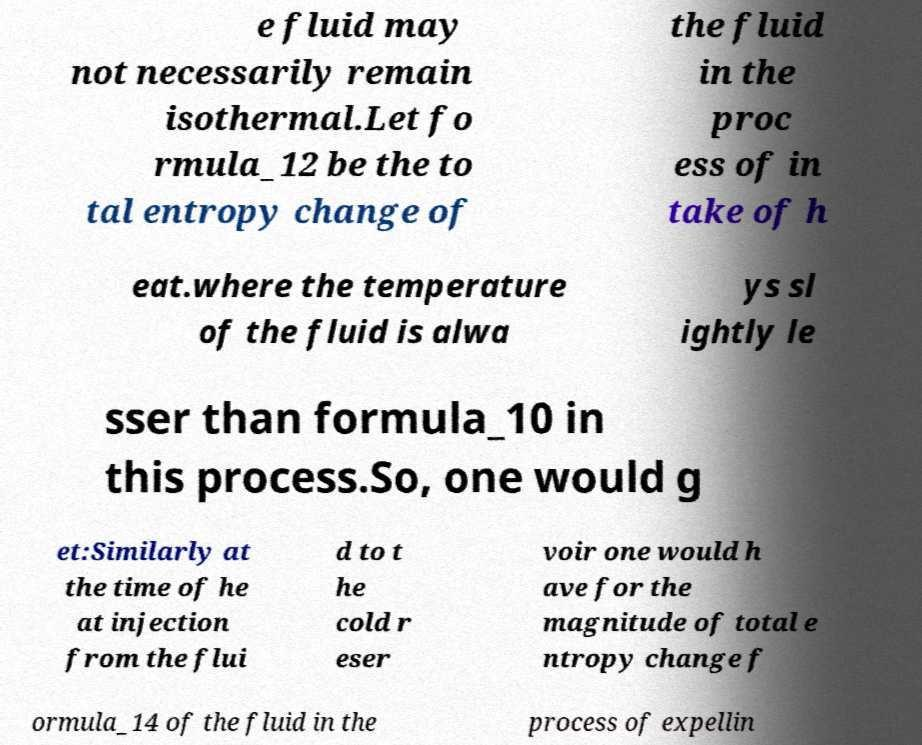Please read and relay the text visible in this image. What does it say? e fluid may not necessarily remain isothermal.Let fo rmula_12 be the to tal entropy change of the fluid in the proc ess of in take of h eat.where the temperature of the fluid is alwa ys sl ightly le sser than formula_10 in this process.So, one would g et:Similarly at the time of he at injection from the flui d to t he cold r eser voir one would h ave for the magnitude of total e ntropy change f ormula_14 of the fluid in the process of expellin 